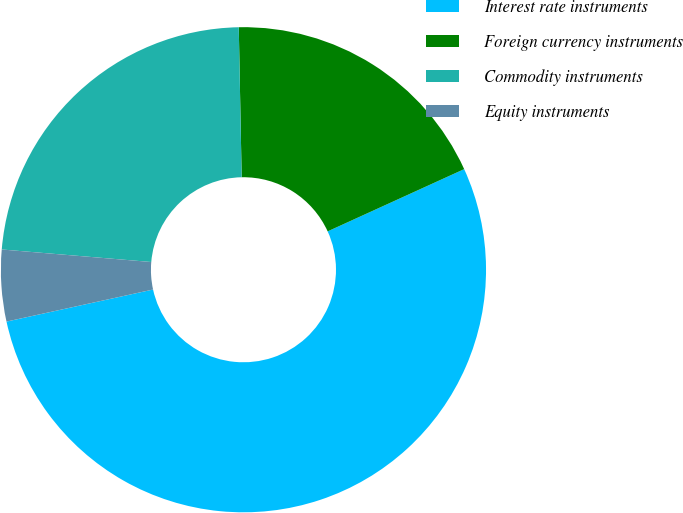<chart> <loc_0><loc_0><loc_500><loc_500><pie_chart><fcel>Interest rate instruments<fcel>Foreign currency instruments<fcel>Commodity instruments<fcel>Equity instruments<nl><fcel>53.38%<fcel>18.5%<fcel>23.36%<fcel>4.76%<nl></chart> 